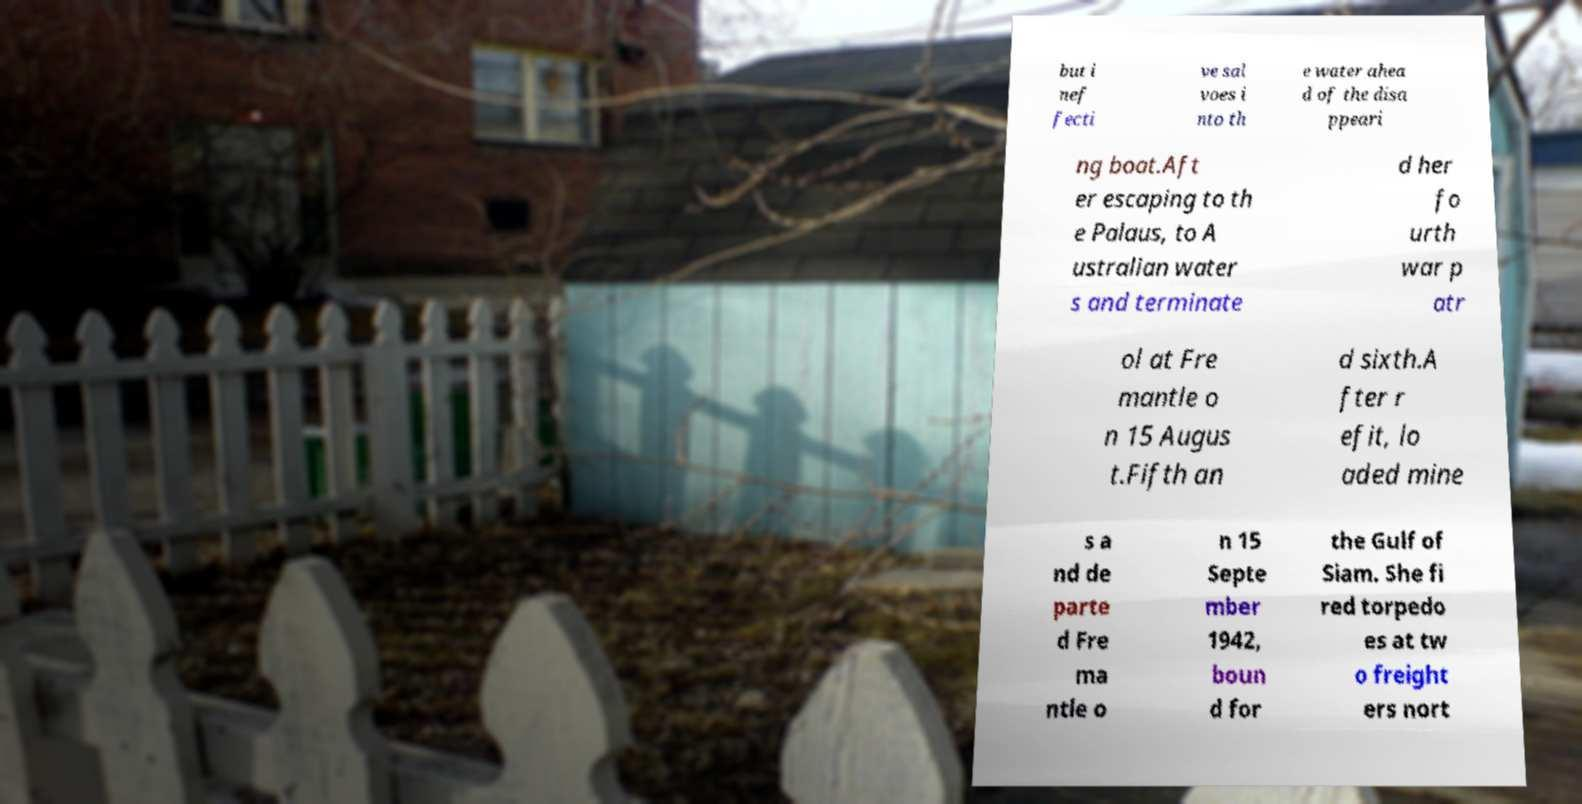Can you read and provide the text displayed in the image?This photo seems to have some interesting text. Can you extract and type it out for me? but i nef fecti ve sal voes i nto th e water ahea d of the disa ppeari ng boat.Aft er escaping to th e Palaus, to A ustralian water s and terminate d her fo urth war p atr ol at Fre mantle o n 15 Augus t.Fifth an d sixth.A fter r efit, lo aded mine s a nd de parte d Fre ma ntle o n 15 Septe mber 1942, boun d for the Gulf of Siam. She fi red torpedo es at tw o freight ers nort 